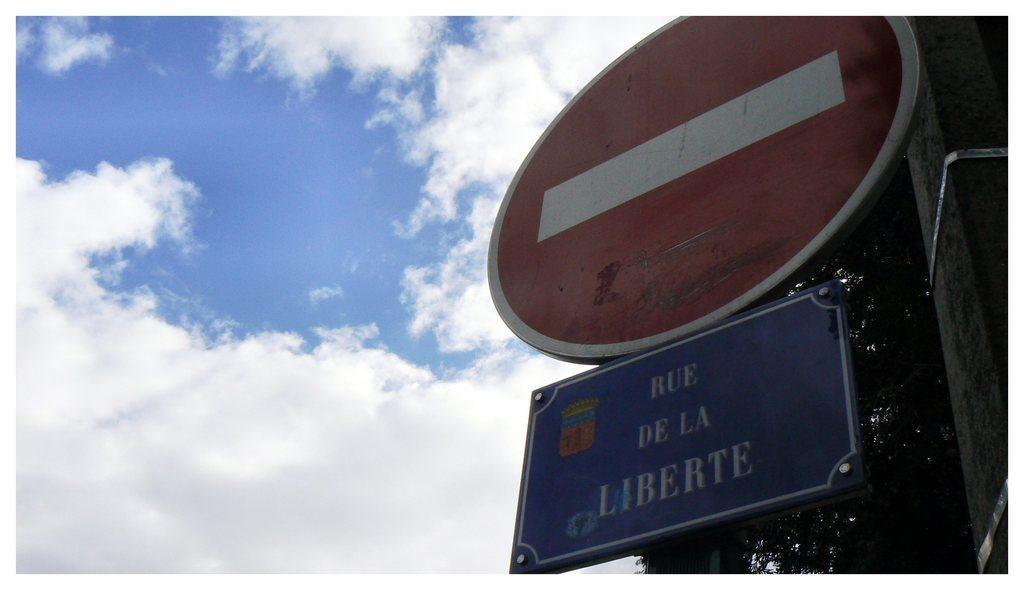Can you describe this image briefly? In this image we can see sky with clouds, pole, trees and sign boards. 